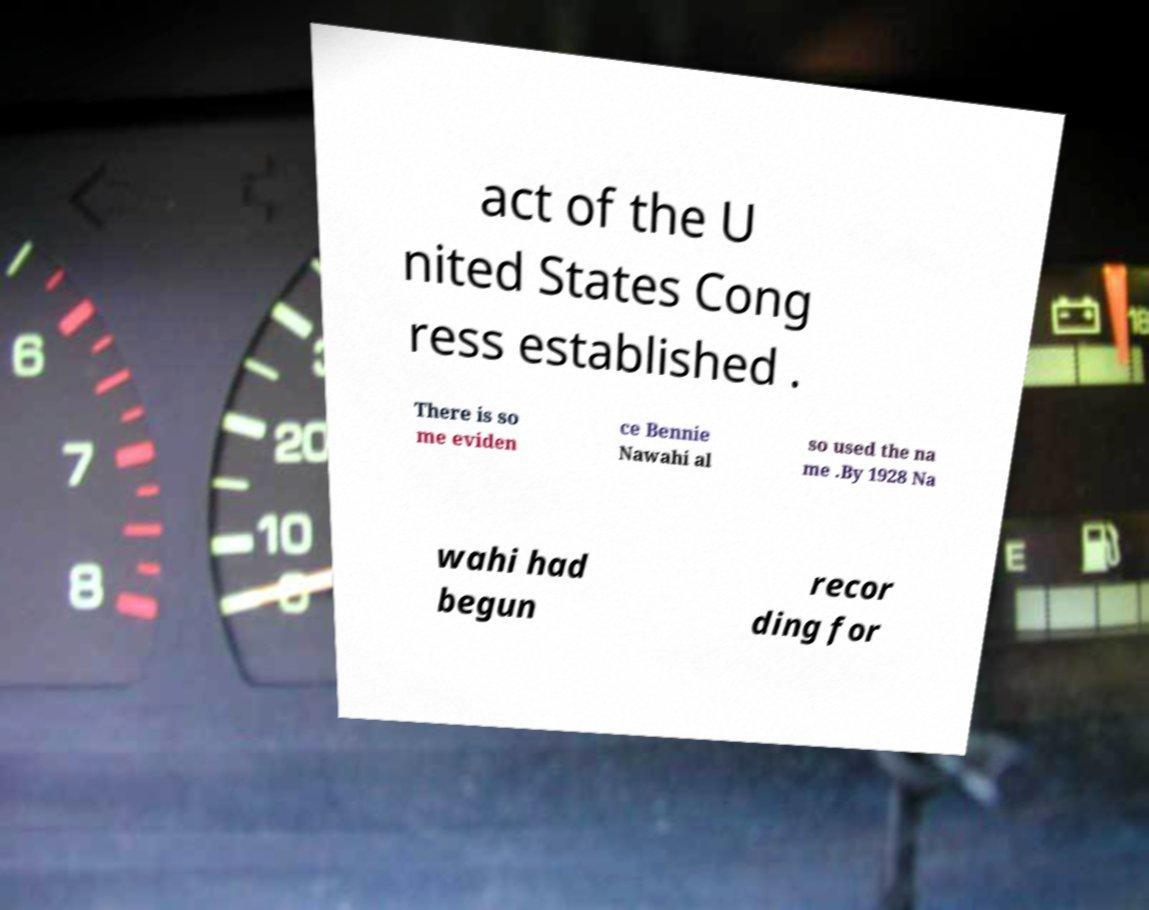I need the written content from this picture converted into text. Can you do that? act of the U nited States Cong ress established . There is so me eviden ce Bennie Nawahi al so used the na me .By 1928 Na wahi had begun recor ding for 